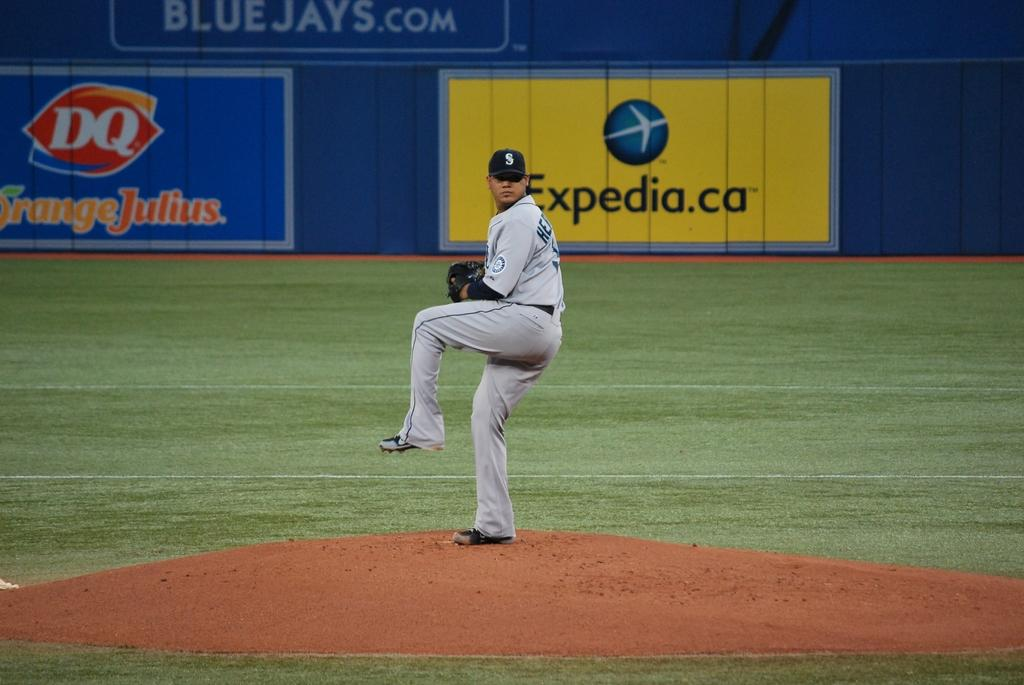<image>
Share a concise interpretation of the image provided. A pitcher is about to throw the baseball at the Blue Jays ballpark. 